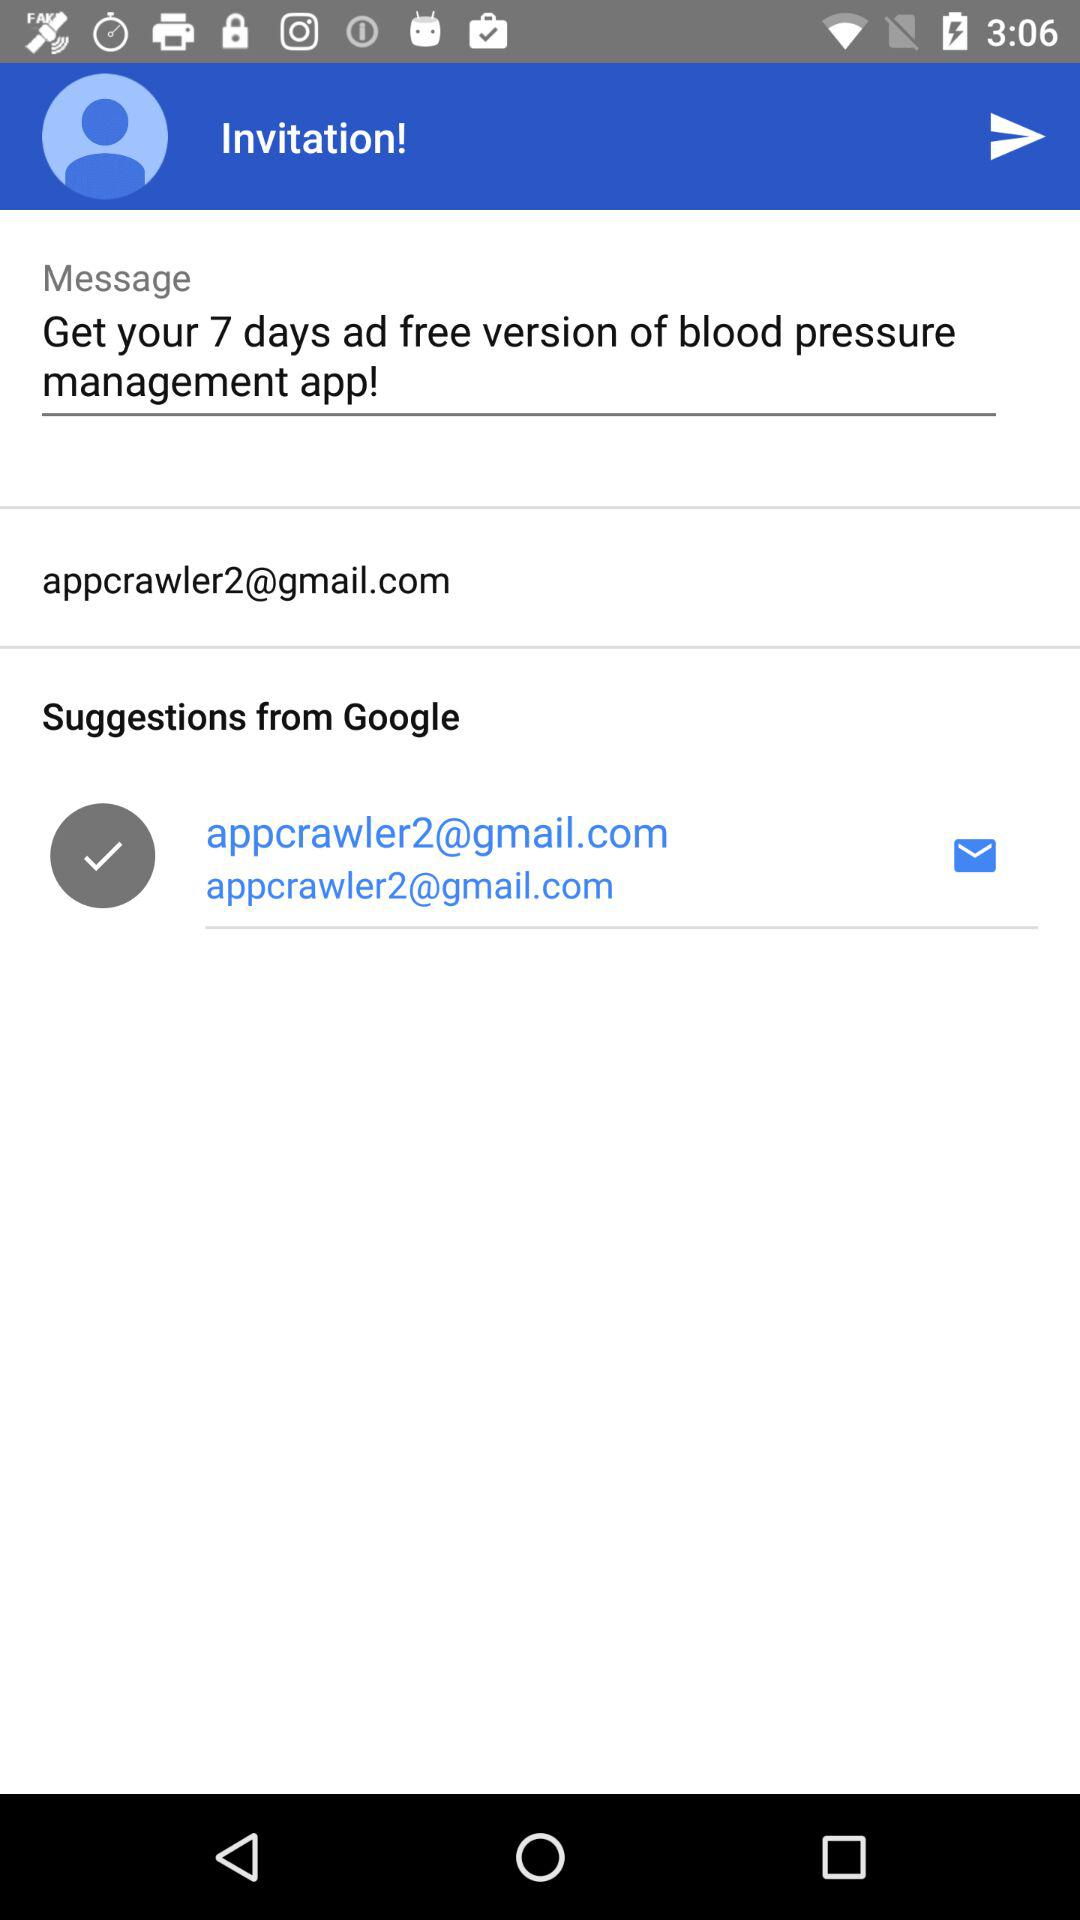What is the email address suggested by Google? The email address suggested by Google is appcrawler2@gmail.com. 